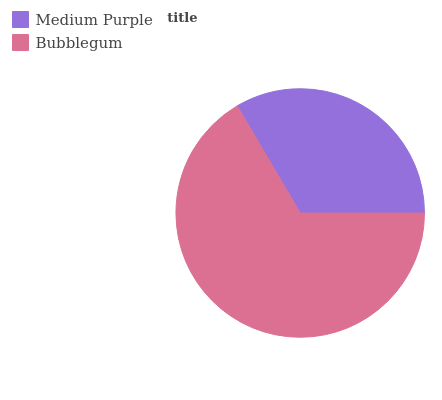Is Medium Purple the minimum?
Answer yes or no. Yes. Is Bubblegum the maximum?
Answer yes or no. Yes. Is Bubblegum the minimum?
Answer yes or no. No. Is Bubblegum greater than Medium Purple?
Answer yes or no. Yes. Is Medium Purple less than Bubblegum?
Answer yes or no. Yes. Is Medium Purple greater than Bubblegum?
Answer yes or no. No. Is Bubblegum less than Medium Purple?
Answer yes or no. No. Is Bubblegum the high median?
Answer yes or no. Yes. Is Medium Purple the low median?
Answer yes or no. Yes. Is Medium Purple the high median?
Answer yes or no. No. Is Bubblegum the low median?
Answer yes or no. No. 